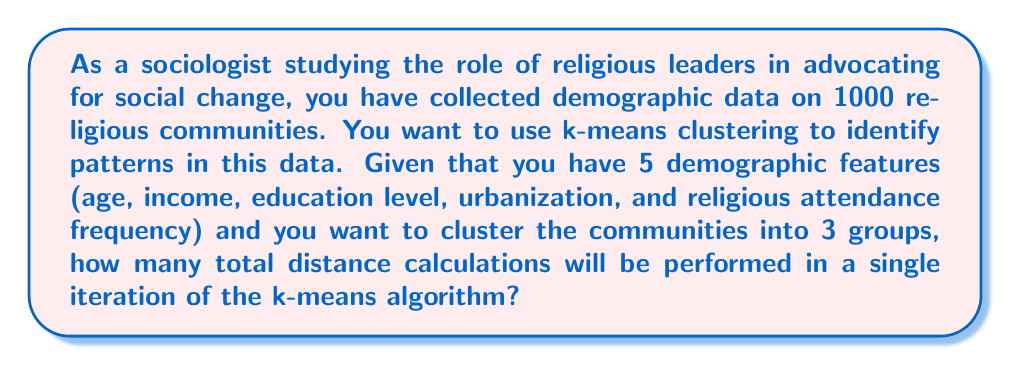Solve this math problem. To solve this problem, we need to understand the k-means algorithm and how it performs distance calculations:

1. In k-means clustering, we calculate the distance between each data point and each cluster centroid.

2. The number of distance calculations per iteration is:
   $$ \text{Number of calculations} = n \times k $$
   Where:
   $n$ is the number of data points
   $k$ is the number of clusters

3. In this case:
   $n = 1000$ (religious communities)
   $k = 3$ (desired number of clusters)

4. Therefore, the number of distance calculations in a single iteration is:
   $$ \text{Number of calculations} = 1000 \times 3 = 3000 $$

5. It's important to note that each distance calculation involves all 5 demographic features, but this doesn't affect the total number of calculations, only the complexity of each calculation.
Answer: 3000 distance calculations 